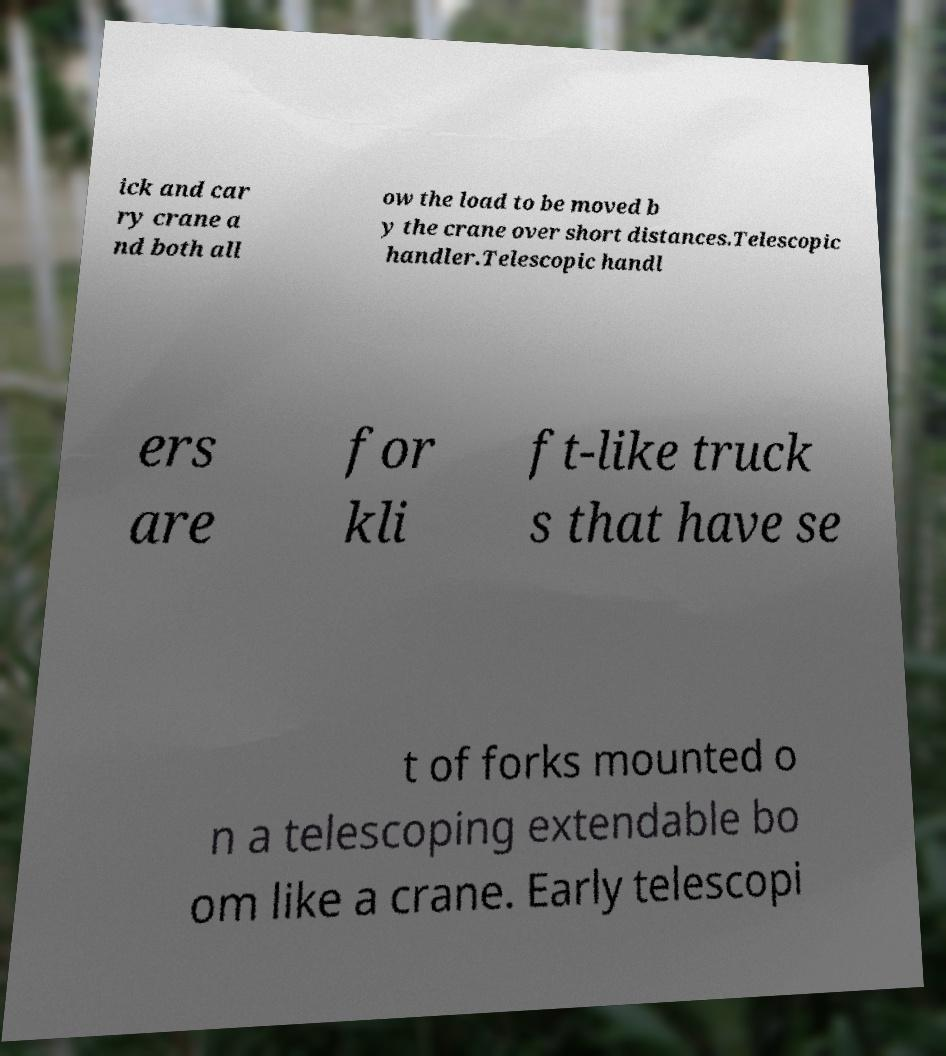What messages or text are displayed in this image? I need them in a readable, typed format. ick and car ry crane a nd both all ow the load to be moved b y the crane over short distances.Telescopic handler.Telescopic handl ers are for kli ft-like truck s that have se t of forks mounted o n a telescoping extendable bo om like a crane. Early telescopi 